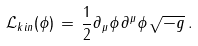<formula> <loc_0><loc_0><loc_500><loc_500>\mathcal { L } _ { k i n } ( \phi ) \, = \, \frac { 1 } { 2 } \partial _ { \mu } \phi \, \partial ^ { \mu } \phi \, \sqrt { - g } \, .</formula> 